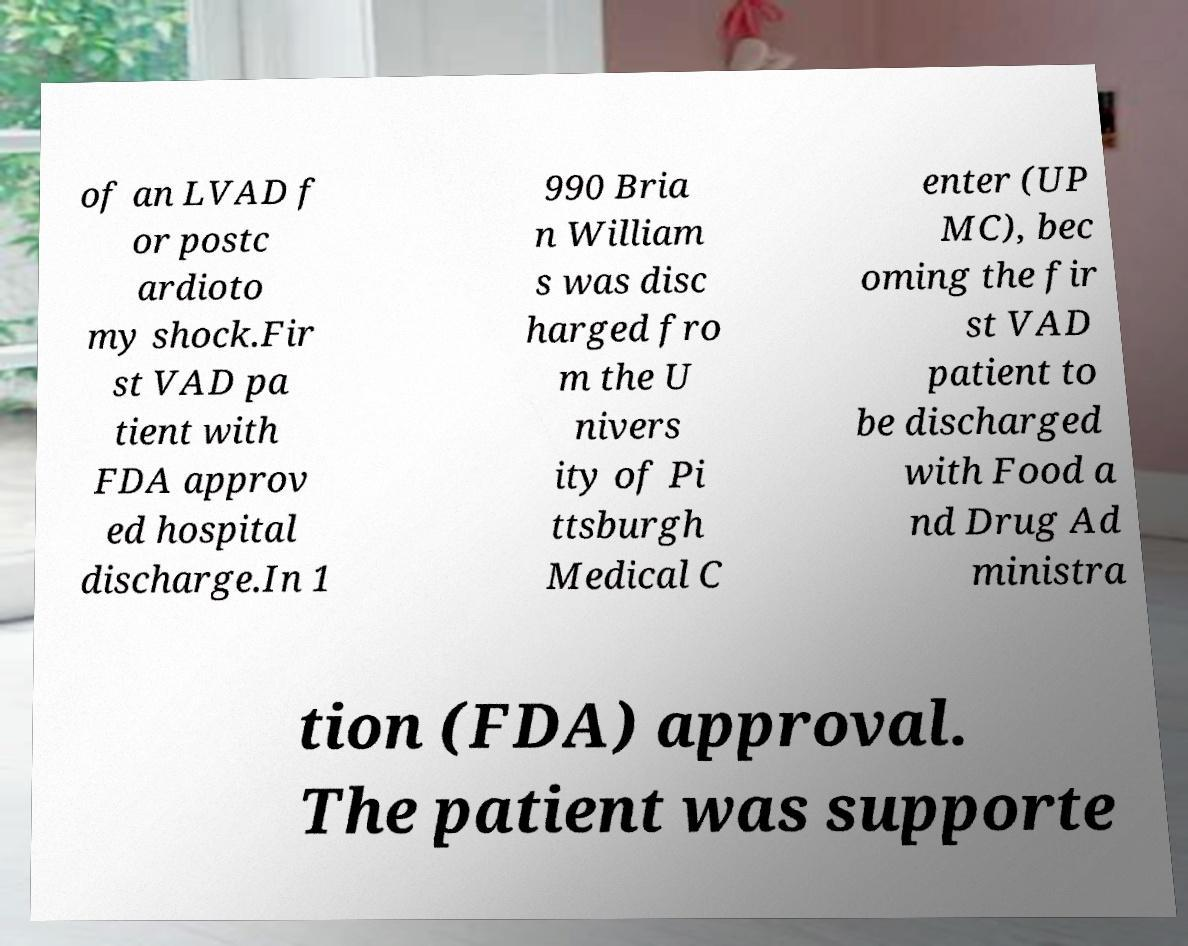Can you read and provide the text displayed in the image?This photo seems to have some interesting text. Can you extract and type it out for me? of an LVAD f or postc ardioto my shock.Fir st VAD pa tient with FDA approv ed hospital discharge.In 1 990 Bria n William s was disc harged fro m the U nivers ity of Pi ttsburgh Medical C enter (UP MC), bec oming the fir st VAD patient to be discharged with Food a nd Drug Ad ministra tion (FDA) approval. The patient was supporte 